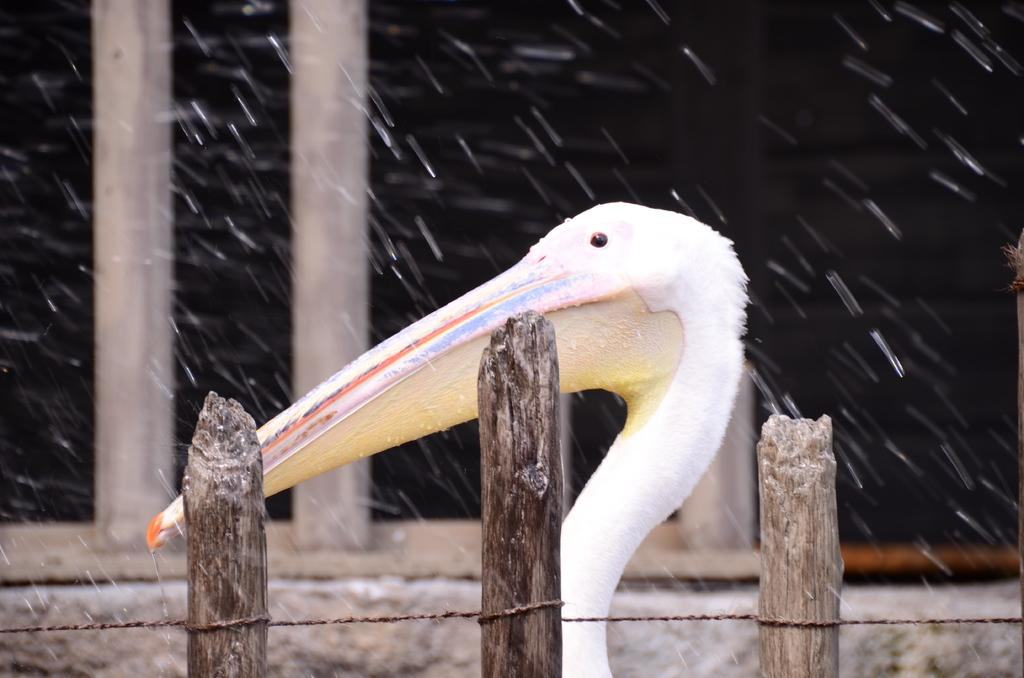What type of animal is in the image? There is a bird in the image. Where is the bird located in relation to the railing? The bird is behind a white railing. What can be seen in the background of the image? There are poles in the background of the image. What is the weather like in the image? The presence of water droplets in the air suggests that it might be raining or humid. How many stones are visible in the image? There are no stones present in the image. What type of geese can be seen swimming in the water in the image? There is no water or geese present in the image; it features a bird behind a white railing and poles in the background. 